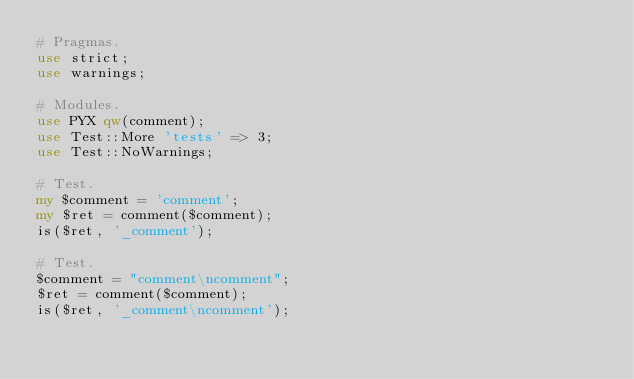Convert code to text. <code><loc_0><loc_0><loc_500><loc_500><_Perl_># Pragmas.
use strict;
use warnings;

# Modules.
use PYX qw(comment);
use Test::More 'tests' => 3;
use Test::NoWarnings;

# Test.
my $comment = 'comment';
my $ret = comment($comment);
is($ret, '_comment');

# Test.
$comment = "comment\ncomment";
$ret = comment($comment);
is($ret, '_comment\ncomment');
</code> 